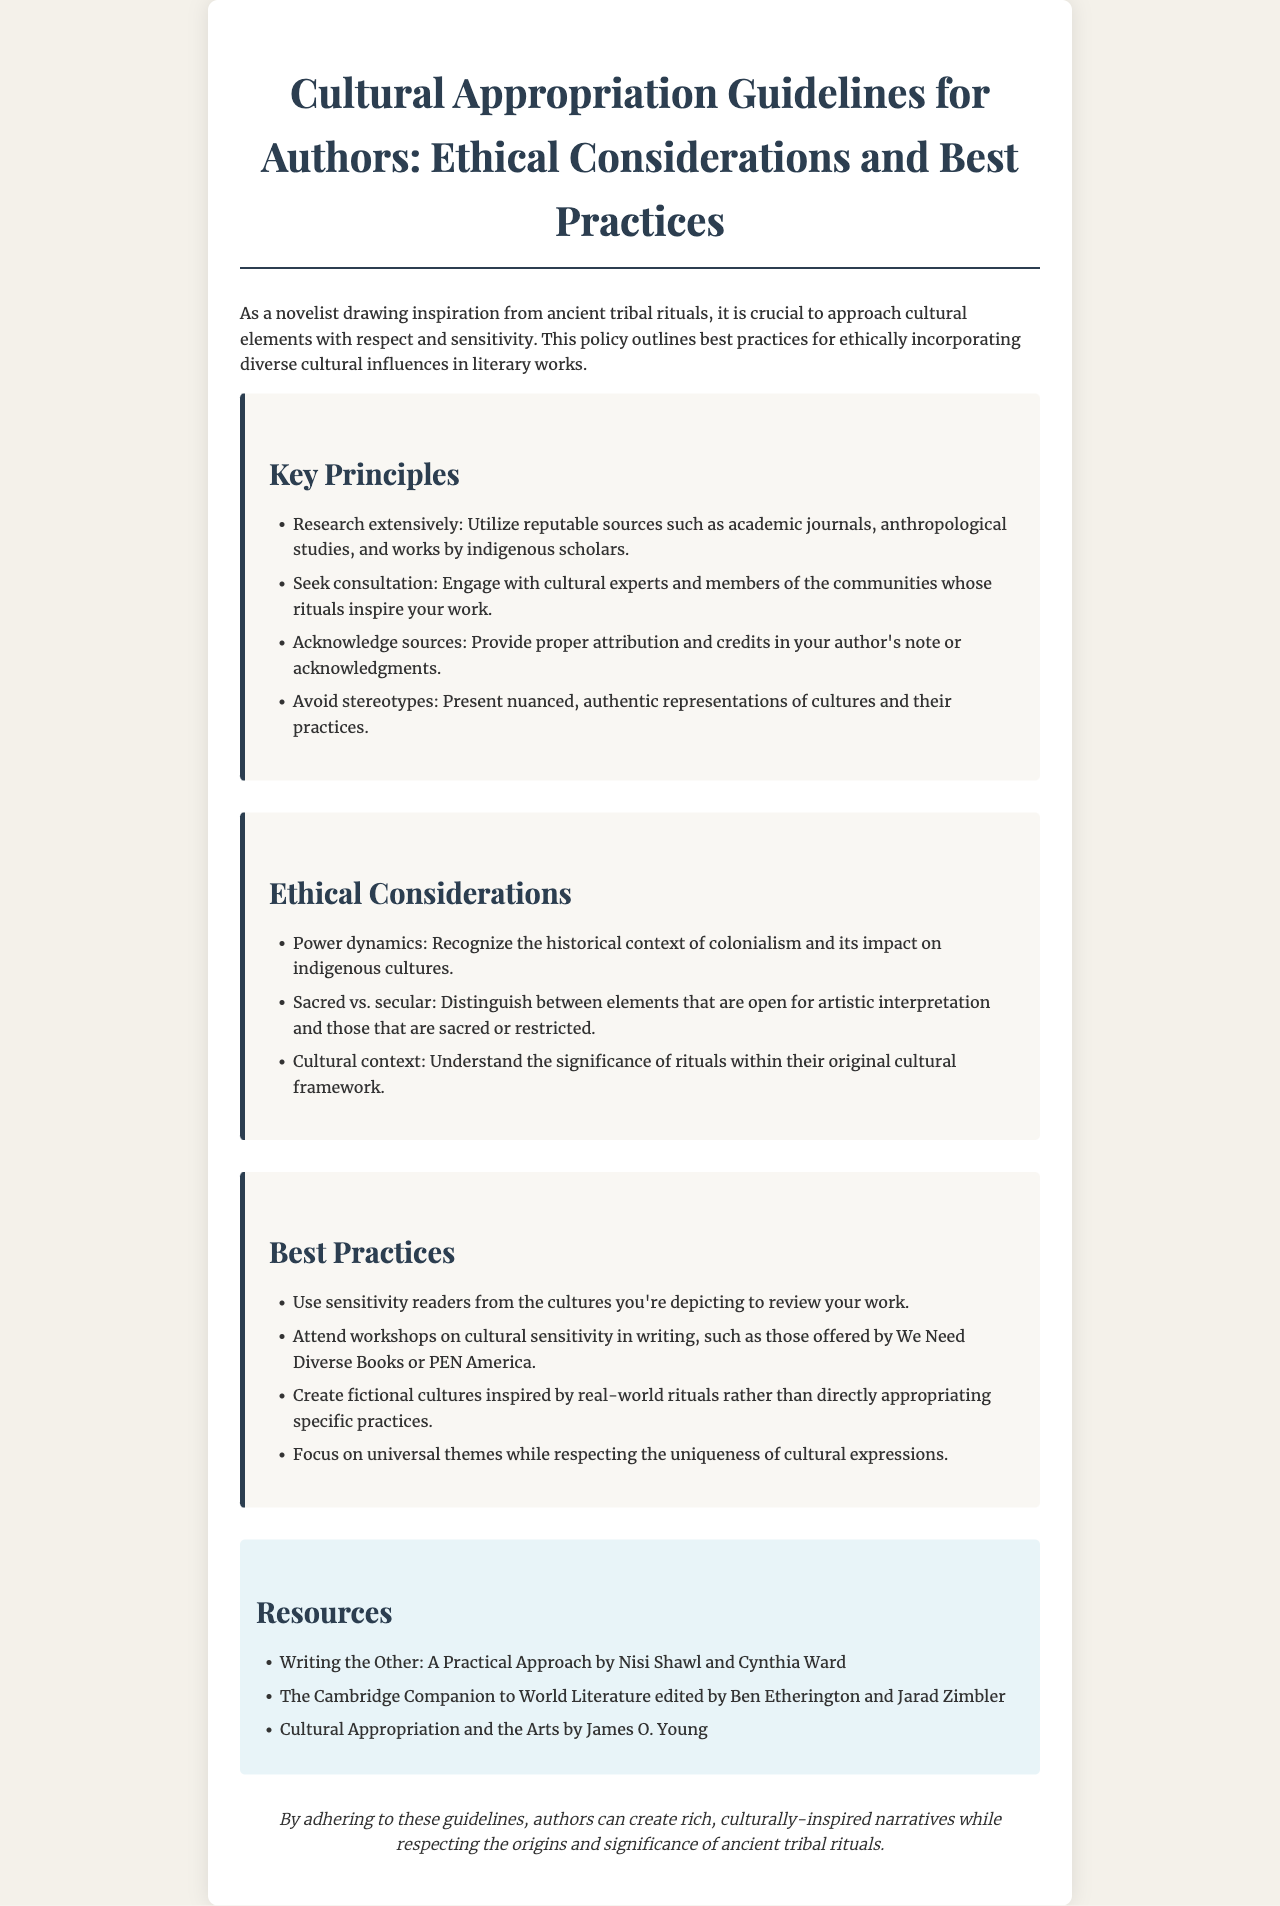what is the title of the document? The title is the main heading of the document, indicating its purpose.
Answer: Cultural Appropriation Guidelines for Authors: Ethical Considerations and Best Practices what is one key principle listed in the document? The document includes a list of key principles for authors to follow.
Answer: Research extensively how many ethical considerations are mentioned in the document? The document lists specific ethical considerations that authors should be aware of when incorporating cultural elements.
Answer: Three who should authors consult according to the guidelines? The guidelines recommend engaging with specific experts to ensure respectful representation.
Answer: Cultural experts and members of the communities what is a best practice suggested in the document? Best practices provide authors with practical advice for their writing process.
Answer: Use sensitivity readers name one resource mentioned in the document. The document provides resources for further reading and understanding on cultural appropriation issues.
Answer: Writing the Other: A Practical Approach by Nisi Shawl and Cynthia Ward what is the major focus of the document? The document is centered around the ethical considerations authors need to keep in mind when writing.
Answer: Respect and sensitivity what theme should authors focus on while respecting cultural expressions? The guidelines emphasize a balance between universal themes and cultural uniqueness.
Answer: Universal themes 